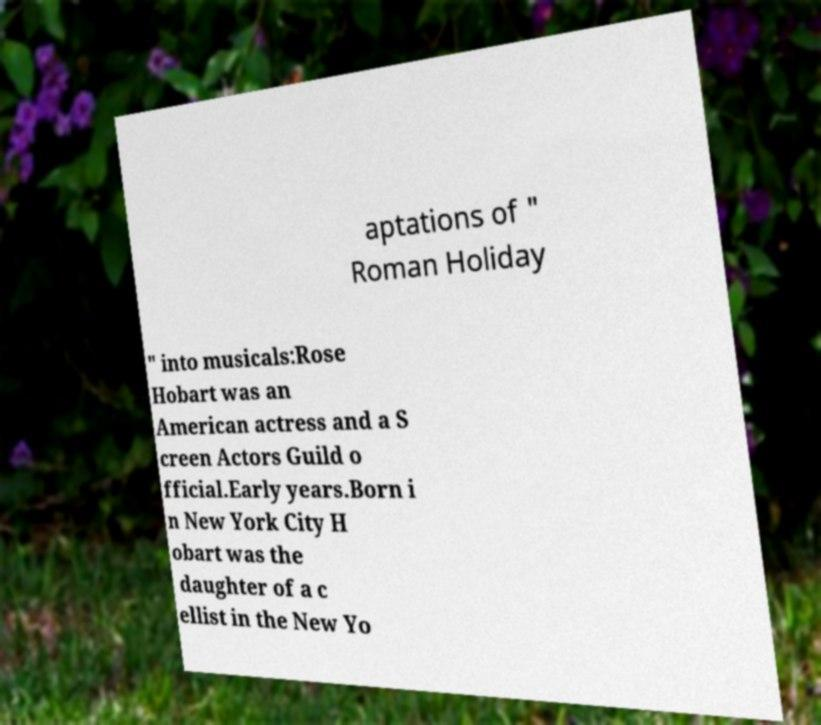For documentation purposes, I need the text within this image transcribed. Could you provide that? aptations of " Roman Holiday " into musicals:Rose Hobart was an American actress and a S creen Actors Guild o fficial.Early years.Born i n New York City H obart was the daughter of a c ellist in the New Yo 